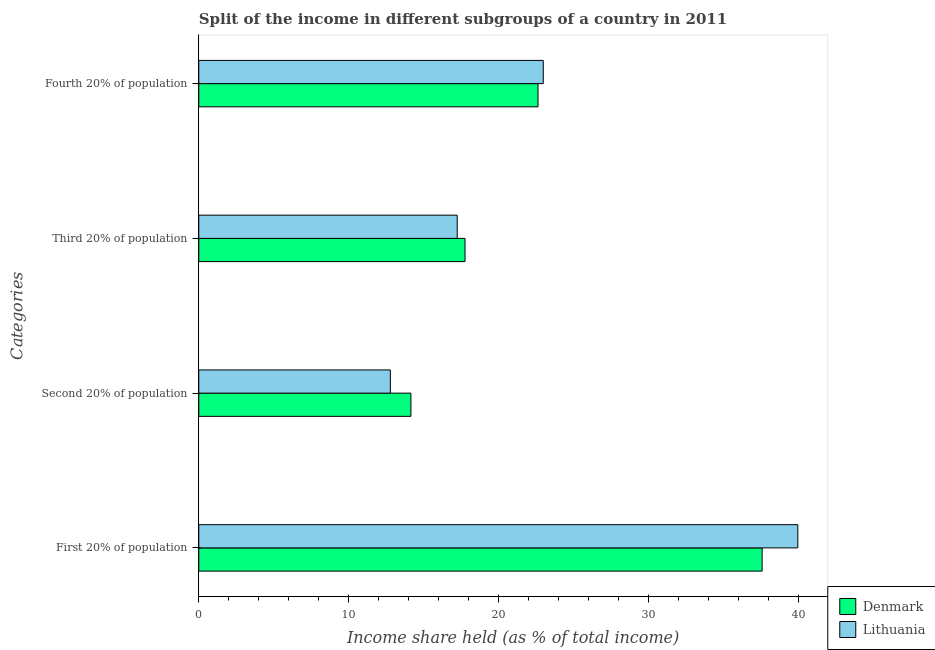How many bars are there on the 1st tick from the top?
Provide a short and direct response. 2. What is the label of the 1st group of bars from the top?
Give a very brief answer. Fourth 20% of population. What is the share of the income held by first 20% of the population in Denmark?
Your answer should be very brief. 37.58. Across all countries, what is the maximum share of the income held by third 20% of the population?
Provide a short and direct response. 17.76. Across all countries, what is the minimum share of the income held by fourth 20% of the population?
Offer a very short reply. 22.63. In which country was the share of the income held by second 20% of the population minimum?
Ensure brevity in your answer.  Lithuania. What is the total share of the income held by first 20% of the population in the graph?
Your answer should be compact. 77.54. What is the difference between the share of the income held by first 20% of the population in Lithuania and that in Denmark?
Provide a succinct answer. 2.38. What is the difference between the share of the income held by first 20% of the population in Denmark and the share of the income held by third 20% of the population in Lithuania?
Give a very brief answer. 20.34. What is the average share of the income held by third 20% of the population per country?
Ensure brevity in your answer.  17.5. What is the difference between the share of the income held by third 20% of the population and share of the income held by first 20% of the population in Lithuania?
Offer a very short reply. -22.72. In how many countries, is the share of the income held by second 20% of the population greater than 38 %?
Provide a succinct answer. 0. What is the ratio of the share of the income held by third 20% of the population in Lithuania to that in Denmark?
Keep it short and to the point. 0.97. What is the difference between the highest and the second highest share of the income held by second 20% of the population?
Provide a short and direct response. 1.37. What is the difference between the highest and the lowest share of the income held by first 20% of the population?
Provide a short and direct response. 2.38. In how many countries, is the share of the income held by fourth 20% of the population greater than the average share of the income held by fourth 20% of the population taken over all countries?
Give a very brief answer. 1. Is it the case that in every country, the sum of the share of the income held by fourth 20% of the population and share of the income held by third 20% of the population is greater than the sum of share of the income held by second 20% of the population and share of the income held by first 20% of the population?
Ensure brevity in your answer.  No. What does the 2nd bar from the bottom in Fourth 20% of population represents?
Offer a terse response. Lithuania. Is it the case that in every country, the sum of the share of the income held by first 20% of the population and share of the income held by second 20% of the population is greater than the share of the income held by third 20% of the population?
Provide a short and direct response. Yes. How many bars are there?
Make the answer very short. 8. Are all the bars in the graph horizontal?
Offer a very short reply. Yes. How many countries are there in the graph?
Provide a short and direct response. 2. What is the difference between two consecutive major ticks on the X-axis?
Your answer should be compact. 10. Does the graph contain any zero values?
Provide a short and direct response. No. How many legend labels are there?
Your response must be concise. 2. What is the title of the graph?
Offer a terse response. Split of the income in different subgroups of a country in 2011. Does "Monaco" appear as one of the legend labels in the graph?
Provide a succinct answer. No. What is the label or title of the X-axis?
Offer a very short reply. Income share held (as % of total income). What is the label or title of the Y-axis?
Provide a short and direct response. Categories. What is the Income share held (as % of total income) of Denmark in First 20% of population?
Your response must be concise. 37.58. What is the Income share held (as % of total income) of Lithuania in First 20% of population?
Give a very brief answer. 39.96. What is the Income share held (as % of total income) of Denmark in Second 20% of population?
Ensure brevity in your answer.  14.15. What is the Income share held (as % of total income) in Lithuania in Second 20% of population?
Offer a very short reply. 12.78. What is the Income share held (as % of total income) in Denmark in Third 20% of population?
Offer a very short reply. 17.76. What is the Income share held (as % of total income) of Lithuania in Third 20% of population?
Your answer should be compact. 17.24. What is the Income share held (as % of total income) in Denmark in Fourth 20% of population?
Give a very brief answer. 22.63. What is the Income share held (as % of total income) of Lithuania in Fourth 20% of population?
Ensure brevity in your answer.  22.98. Across all Categories, what is the maximum Income share held (as % of total income) in Denmark?
Ensure brevity in your answer.  37.58. Across all Categories, what is the maximum Income share held (as % of total income) of Lithuania?
Ensure brevity in your answer.  39.96. Across all Categories, what is the minimum Income share held (as % of total income) of Denmark?
Provide a short and direct response. 14.15. Across all Categories, what is the minimum Income share held (as % of total income) in Lithuania?
Your answer should be compact. 12.78. What is the total Income share held (as % of total income) in Denmark in the graph?
Your answer should be very brief. 92.12. What is the total Income share held (as % of total income) in Lithuania in the graph?
Offer a terse response. 92.96. What is the difference between the Income share held (as % of total income) of Denmark in First 20% of population and that in Second 20% of population?
Provide a succinct answer. 23.43. What is the difference between the Income share held (as % of total income) in Lithuania in First 20% of population and that in Second 20% of population?
Your answer should be very brief. 27.18. What is the difference between the Income share held (as % of total income) in Denmark in First 20% of population and that in Third 20% of population?
Your response must be concise. 19.82. What is the difference between the Income share held (as % of total income) in Lithuania in First 20% of population and that in Third 20% of population?
Offer a very short reply. 22.72. What is the difference between the Income share held (as % of total income) of Denmark in First 20% of population and that in Fourth 20% of population?
Ensure brevity in your answer.  14.95. What is the difference between the Income share held (as % of total income) in Lithuania in First 20% of population and that in Fourth 20% of population?
Provide a short and direct response. 16.98. What is the difference between the Income share held (as % of total income) of Denmark in Second 20% of population and that in Third 20% of population?
Make the answer very short. -3.61. What is the difference between the Income share held (as % of total income) in Lithuania in Second 20% of population and that in Third 20% of population?
Your response must be concise. -4.46. What is the difference between the Income share held (as % of total income) in Denmark in Second 20% of population and that in Fourth 20% of population?
Give a very brief answer. -8.48. What is the difference between the Income share held (as % of total income) in Lithuania in Second 20% of population and that in Fourth 20% of population?
Make the answer very short. -10.2. What is the difference between the Income share held (as % of total income) in Denmark in Third 20% of population and that in Fourth 20% of population?
Keep it short and to the point. -4.87. What is the difference between the Income share held (as % of total income) of Lithuania in Third 20% of population and that in Fourth 20% of population?
Keep it short and to the point. -5.74. What is the difference between the Income share held (as % of total income) of Denmark in First 20% of population and the Income share held (as % of total income) of Lithuania in Second 20% of population?
Offer a terse response. 24.8. What is the difference between the Income share held (as % of total income) in Denmark in First 20% of population and the Income share held (as % of total income) in Lithuania in Third 20% of population?
Provide a short and direct response. 20.34. What is the difference between the Income share held (as % of total income) of Denmark in First 20% of population and the Income share held (as % of total income) of Lithuania in Fourth 20% of population?
Provide a succinct answer. 14.6. What is the difference between the Income share held (as % of total income) in Denmark in Second 20% of population and the Income share held (as % of total income) in Lithuania in Third 20% of population?
Make the answer very short. -3.09. What is the difference between the Income share held (as % of total income) of Denmark in Second 20% of population and the Income share held (as % of total income) of Lithuania in Fourth 20% of population?
Offer a terse response. -8.83. What is the difference between the Income share held (as % of total income) of Denmark in Third 20% of population and the Income share held (as % of total income) of Lithuania in Fourth 20% of population?
Offer a very short reply. -5.22. What is the average Income share held (as % of total income) of Denmark per Categories?
Ensure brevity in your answer.  23.03. What is the average Income share held (as % of total income) in Lithuania per Categories?
Provide a succinct answer. 23.24. What is the difference between the Income share held (as % of total income) of Denmark and Income share held (as % of total income) of Lithuania in First 20% of population?
Make the answer very short. -2.38. What is the difference between the Income share held (as % of total income) of Denmark and Income share held (as % of total income) of Lithuania in Second 20% of population?
Offer a very short reply. 1.37. What is the difference between the Income share held (as % of total income) of Denmark and Income share held (as % of total income) of Lithuania in Third 20% of population?
Make the answer very short. 0.52. What is the difference between the Income share held (as % of total income) in Denmark and Income share held (as % of total income) in Lithuania in Fourth 20% of population?
Give a very brief answer. -0.35. What is the ratio of the Income share held (as % of total income) in Denmark in First 20% of population to that in Second 20% of population?
Keep it short and to the point. 2.66. What is the ratio of the Income share held (as % of total income) of Lithuania in First 20% of population to that in Second 20% of population?
Offer a very short reply. 3.13. What is the ratio of the Income share held (as % of total income) in Denmark in First 20% of population to that in Third 20% of population?
Ensure brevity in your answer.  2.12. What is the ratio of the Income share held (as % of total income) in Lithuania in First 20% of population to that in Third 20% of population?
Offer a terse response. 2.32. What is the ratio of the Income share held (as % of total income) of Denmark in First 20% of population to that in Fourth 20% of population?
Keep it short and to the point. 1.66. What is the ratio of the Income share held (as % of total income) in Lithuania in First 20% of population to that in Fourth 20% of population?
Your answer should be very brief. 1.74. What is the ratio of the Income share held (as % of total income) in Denmark in Second 20% of population to that in Third 20% of population?
Your answer should be very brief. 0.8. What is the ratio of the Income share held (as % of total income) of Lithuania in Second 20% of population to that in Third 20% of population?
Make the answer very short. 0.74. What is the ratio of the Income share held (as % of total income) of Denmark in Second 20% of population to that in Fourth 20% of population?
Keep it short and to the point. 0.63. What is the ratio of the Income share held (as % of total income) in Lithuania in Second 20% of population to that in Fourth 20% of population?
Provide a short and direct response. 0.56. What is the ratio of the Income share held (as % of total income) in Denmark in Third 20% of population to that in Fourth 20% of population?
Your response must be concise. 0.78. What is the ratio of the Income share held (as % of total income) of Lithuania in Third 20% of population to that in Fourth 20% of population?
Keep it short and to the point. 0.75. What is the difference between the highest and the second highest Income share held (as % of total income) of Denmark?
Keep it short and to the point. 14.95. What is the difference between the highest and the second highest Income share held (as % of total income) in Lithuania?
Ensure brevity in your answer.  16.98. What is the difference between the highest and the lowest Income share held (as % of total income) in Denmark?
Offer a very short reply. 23.43. What is the difference between the highest and the lowest Income share held (as % of total income) in Lithuania?
Offer a terse response. 27.18. 